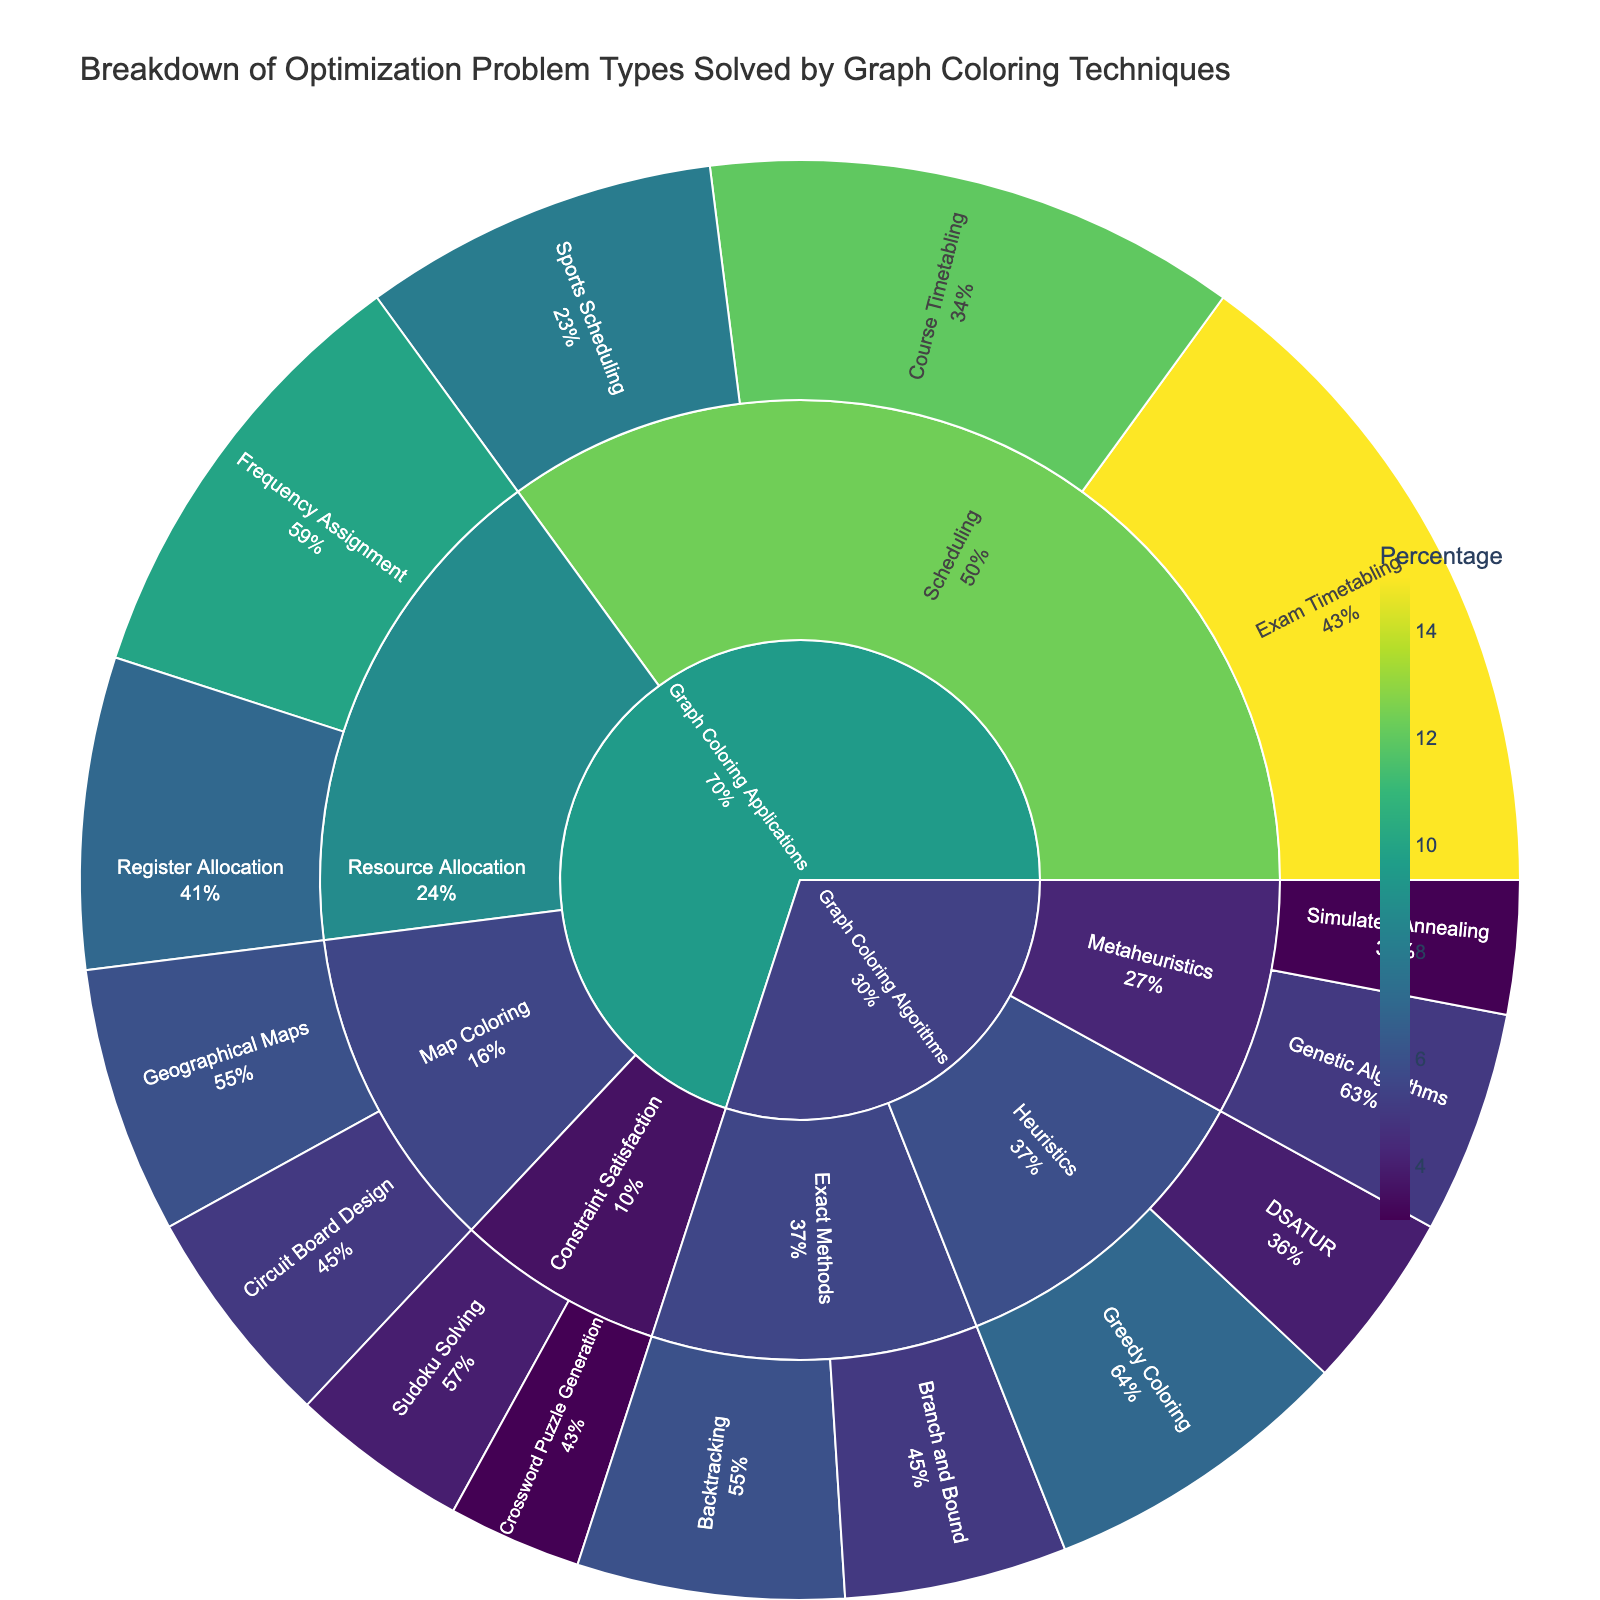What is the title of the plot? The title is usually displayed at the top of the plot, indicating the main subject of the visualization. By looking at the top section, you can see the title "Breakdown of Optimization Problem Types Solved by Graph Coloring Techniques".
Answer: Breakdown of Optimization Problem Types Solved by Graph Coloring Techniques How many main categories are represented in the Sunburst Plot? In a Sunburst Plot, the main categories are the outermost sections directly connected to the center. Here, there are two main categories labeled "Graph Coloring Applications" and "Graph Coloring Algorithms".
Answer: 2 Which problem type within "Scheduling" has the highest percentage? To find this, first locate the "Scheduling" subcategory within the "Graph Coloring Applications" category, then compare the percentages of its child problem types (Exam Timetabling, Course Timetabling, Sports Scheduling). The problem type with the highest percentage is Exam Timetabling at 15%.
Answer: Exam Timetabling What is the combined percentage for problem types under "Resource Allocation"? The "Resource Allocation" subcategory under "Graph Coloring Applications" includes Frequency Assignment (10%) and Register Allocation (7%). Adding these together gives a total of 10% + 7% = 17%.
Answer: 17% Which had a higher percentage: "Geographical Maps" under Map Coloring or "Simulated Annealing" under Metaheuristics? In the Sunburst Plot, compare the percentage values for "Geographical Maps" (6%) and "Simulated Annealing" (3%). "Geographical Maps" has a higher percentage.
Answer: Geographical Maps What is the sum of percentages for "Exact Methods" under "Graph Coloring Algorithms"? The "Exact Methods" includes Backtracking (6%) and Branch and Bound (5%). Summing these percentages gives 6% + 5% = 11%.
Answer: 11% Which subcategory among "Graph Coloring Applications" has the least combined percentage? Examine the subcategories under "Graph Coloring Applications" and sum their respective percentages: Scheduling (15% + 12% + 8% = 35%), Resource Allocation (10% + 7% = 17%), Map Coloring (6% + 5% = 11%), Constraint Satisfaction (4% + 3% = 7%). Constraint Satisfaction has the least combined percentage of 7%.
Answer: Constraint Satisfaction Which subcategory under "Graph Coloring Algorithms" has more problem types, and how many more? The subcategories under "Graph Coloring Algorithms" are "Exact Methods", "Heuristics", and "Metaheuristics". Exact Methods (2 problem types), Heuristics (2 problem types), Metaheuristics (2 problem types). Since all subcategories have equal problem types, none has more than another.
Answer: None Is the percentage of "Greedy Coloring" higher than "DSATUR"? The percentages given for "Greedy Coloring" in Heuristics is 7%, and for "DSATUR" is 4%. Since 7% > 4%, "Greedy Coloring" has a higher percentage.
Answer: Yes 